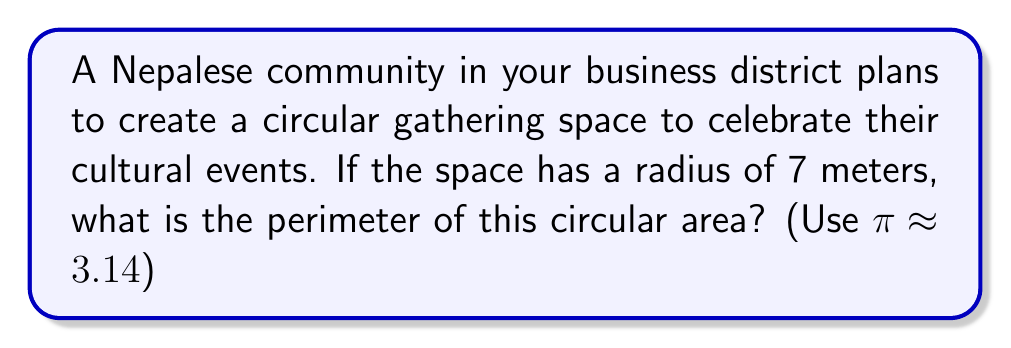Show me your answer to this math problem. Let's approach this step-by-step:

1) The perimeter of a circle is also known as its circumference.

2) The formula for the circumference of a circle is:

   $$C = 2\pi r$$

   where $C$ is the circumference, $\pi$ is pi, and $r$ is the radius.

3) We're given that the radius is 7 meters and $\pi \approx 3.14$.

4) Let's substitute these values into our formula:

   $$C = 2 \times 3.14 \times 7$$

5) Now, let's calculate:

   $$C = 6.28 \times 7 = 43.96$$

6) Rounding to two decimal places:

   $$C \approx 43.96 \text{ meters}$$

Therefore, the perimeter of the circular gathering space is approximately 43.96 meters.
Answer: $43.96 \text{ m}$ 